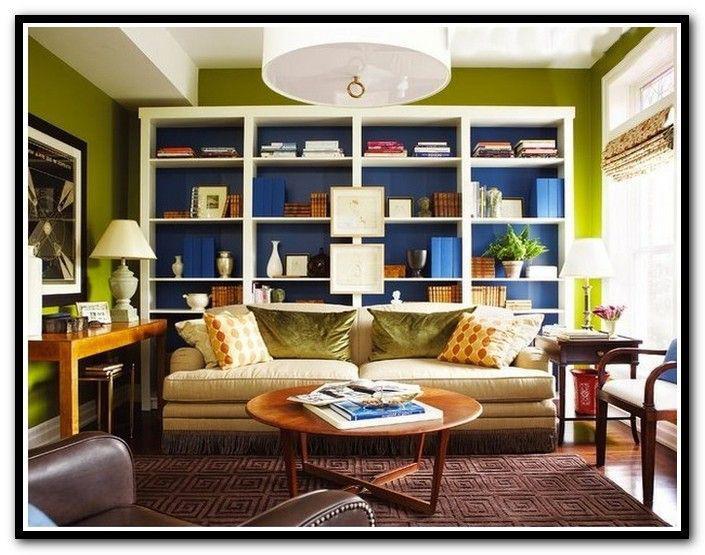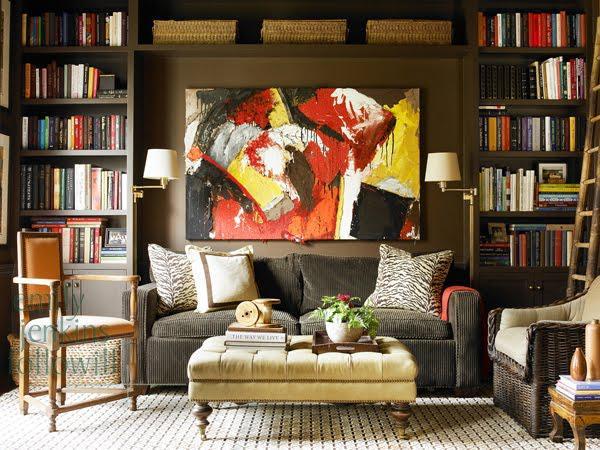The first image is the image on the left, the second image is the image on the right. Given the left and right images, does the statement "There are two lamps with pale shades mounted on the wall behind the couch in one of the images." hold true? Answer yes or no. Yes. The first image is the image on the left, the second image is the image on the right. Evaluate the accuracy of this statement regarding the images: "in the left image there is a tall window near a book case". Is it true? Answer yes or no. Yes. 